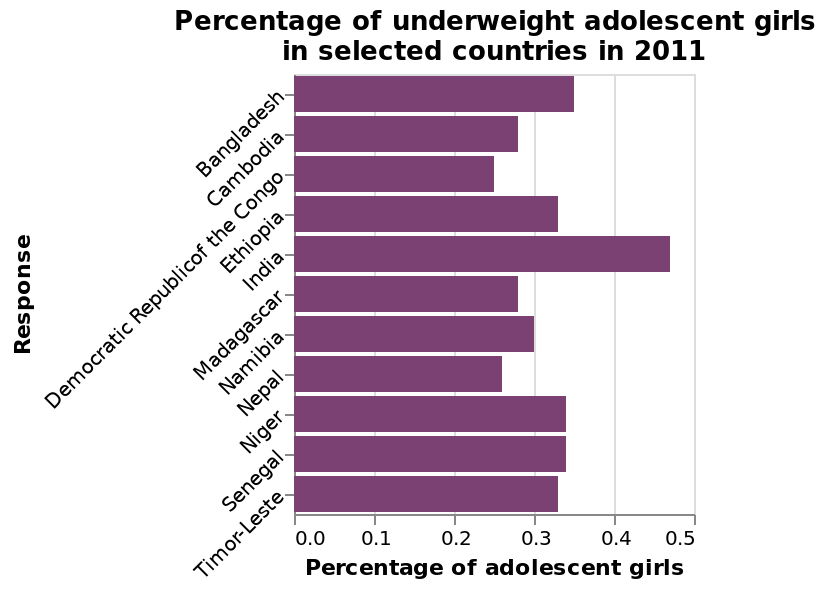<image>
What information does the bar plot provide for each country? The bar plot provides the information about the "Percentage of underweight adolescent girls" for each selected country in the year 2011. What is the range of percentage points for underweight girls in general?  The range of percentage points for underweight girls in general is 0.0-0.50, which is fairly low. What is the percentage of underweight girls in Bangladesh?  The chart does not provide the specific percentage of underweight girls in Bangladesh. It only states that Bangladesh has a high percentage among the countries mentioned. Which country has the lowest percentage of underweight girls?  Nepal has the lowest percentage of underweight girls. 